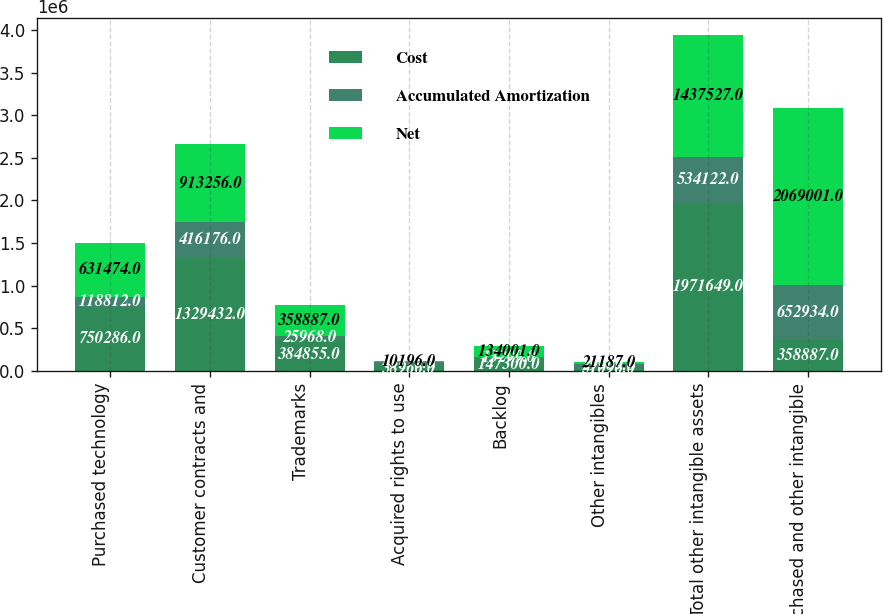Convert chart. <chart><loc_0><loc_0><loc_500><loc_500><stacked_bar_chart><ecel><fcel>Purchased technology<fcel>Customer contracts and<fcel>Trademarks<fcel>Acquired rights to use<fcel>Backlog<fcel>Other intangibles<fcel>Total other intangible assets<fcel>Purchased and other intangible<nl><fcel>Cost<fcel>750286<fcel>1.32943e+06<fcel>384855<fcel>58966<fcel>147300<fcel>51096<fcel>1.97165e+06<fcel>358887<nl><fcel>Accumulated Amortization<fcel>118812<fcel>416176<fcel>25968<fcel>48770<fcel>13299<fcel>29909<fcel>534122<fcel>652934<nl><fcel>Net<fcel>631474<fcel>913256<fcel>358887<fcel>10196<fcel>134001<fcel>21187<fcel>1.43753e+06<fcel>2.069e+06<nl></chart> 